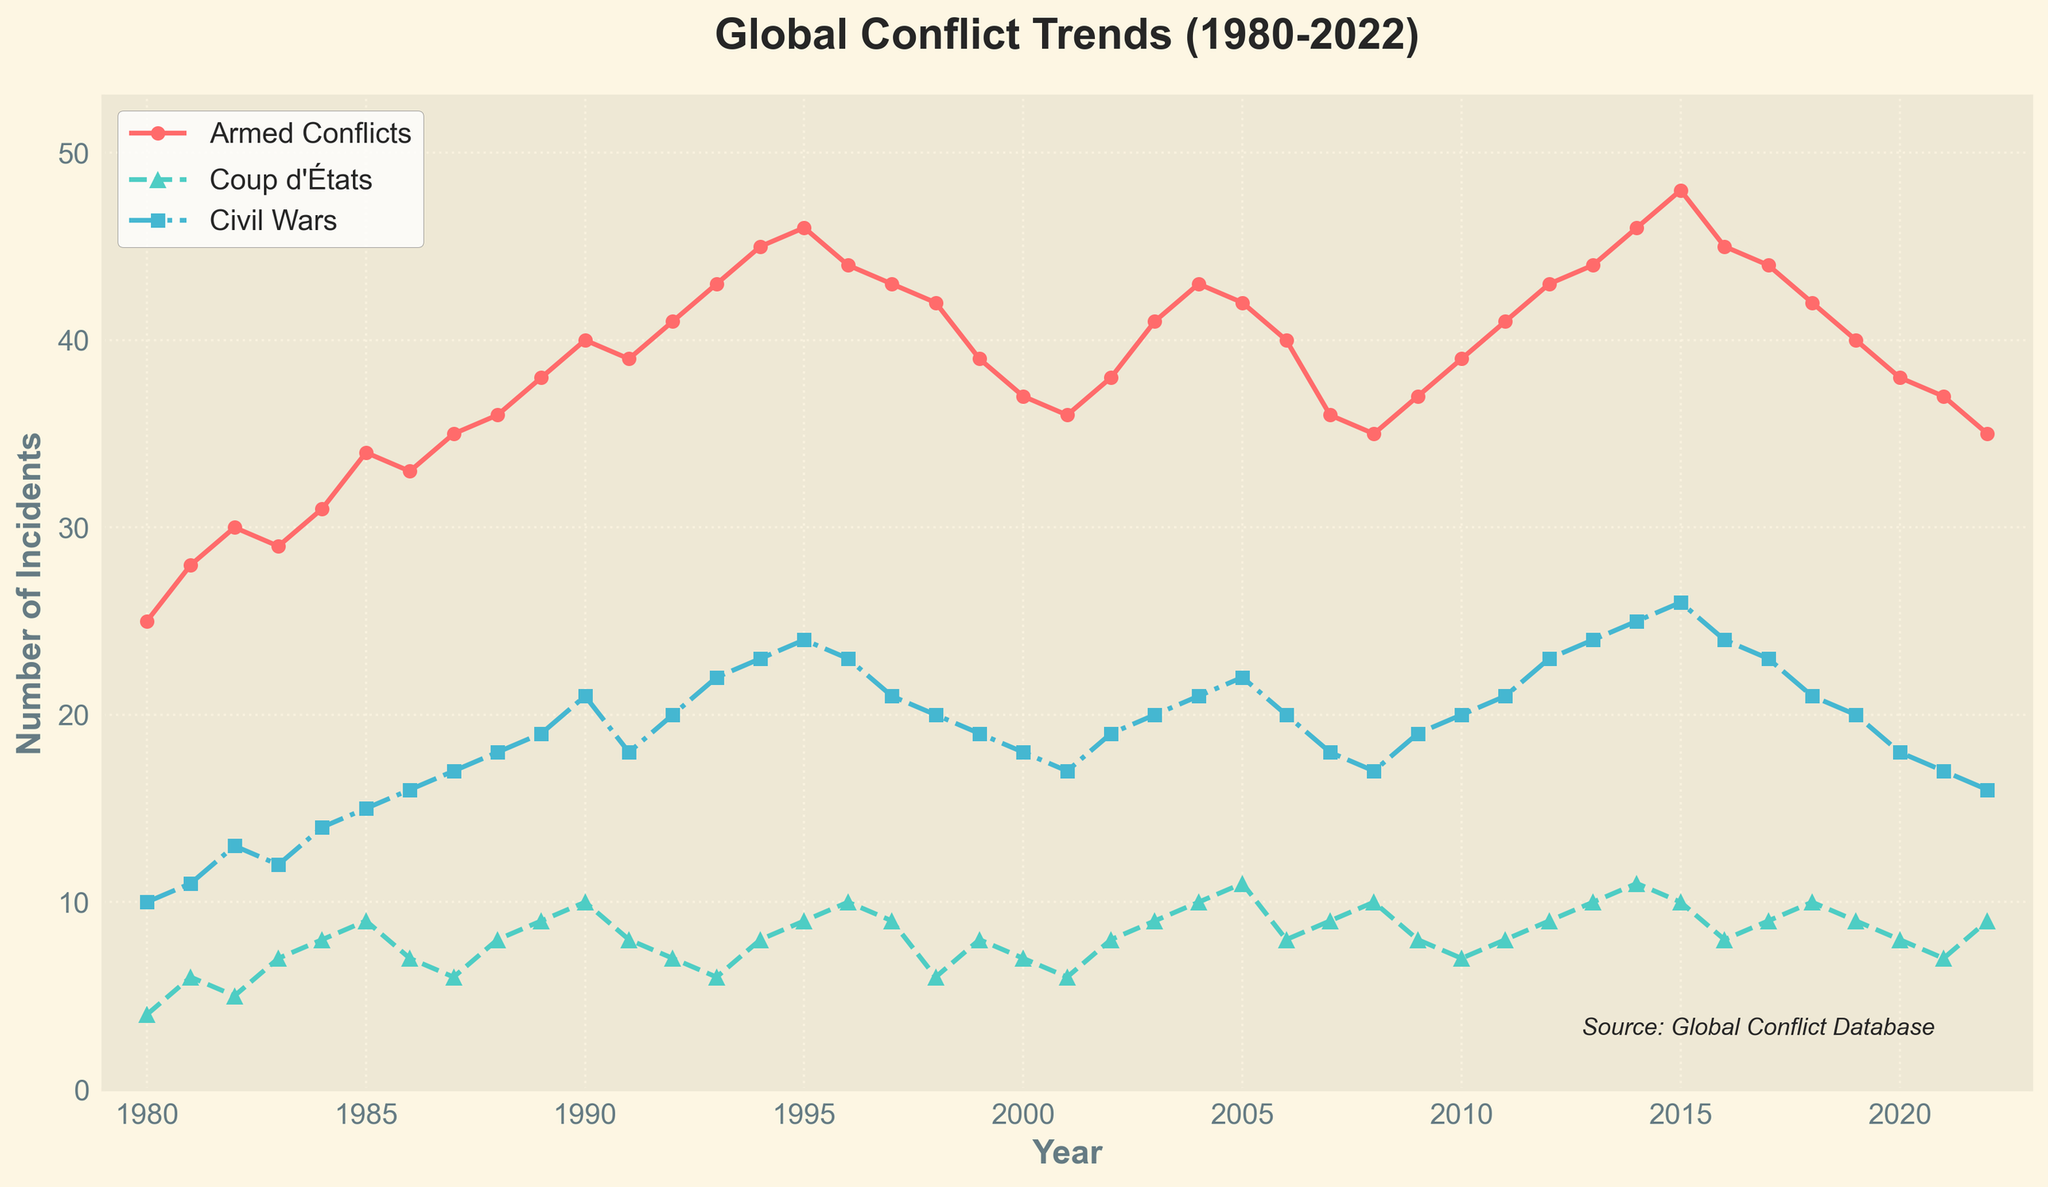What is the trend in the number of armed conflicts from 1980 to 2022? From 1980 to 2022, the number of armed conflicts generally shows an upward trend, with some fluctuations. It begins at 25 in 1980, peaks at 48 in 2015, and then decreases to 35 in 2022.
Answer: Increasing with fluctuations How many coup d'états were there in 1995? Look at the data point for the year 1995 under the line representing coup d'états. The value is 9.
Answer: 9 Which year observed the highest number of civil wars? Observe the peaks in the civil wars line. The highest point is in 2015 with 26 civil wars.
Answer: 2015 How does the number of armed conflicts in 2000 compare to 2010? Identify the data points for 2000 and 2010 in the armed conflicts line. There were 37 in 2000 and 39 in 2010, showing a slight increase.
Answer: Slightly higher in 2010 Calculate the average number of coup d'états per year from 2000 to 2010. Count the number of coup d'état data points from 2000 to 2010 and sum them: (7+6+8+9+10+11+8+9+10+7+8). The sum is 93, and there are 11 years, giving an average of 93/11.
Answer: 8.45 What overall trend is observed in the number of civil wars from 1980 to 2022? From 1980 to 2022, the number of civil wars generally shows an increasing trend, with the number starting at 10 in 1980, peaking at 26 in 2015, and then slightly declining to 16 in 2022.
Answer: Increasing with fluctuations Between which consecutive years did the number of armed conflicts show the most considerable increase? Calculate the difference between consecutive years for armed conflicts. The most significant increase is between 2014 and 2015, where it increased from 46 to 48.
Answer: 2014 to 2015 Which conflict type showed the least variation in the number of incidents over the years? Compare the ranges (difference between max and min values) of the three conflict types. Coup d'états have the smallest range (11 - 4 = 7), indicating the least variation.
Answer: Coup d'états Is there any year where the number of coup d'états and civil wars were equal? Compare the number of coup d'états and civil wars year by year. In 1981 (6), 1987 (6), 1997 (9), and 2022 (9), they were equal.
Answer: Yes, multiple years 